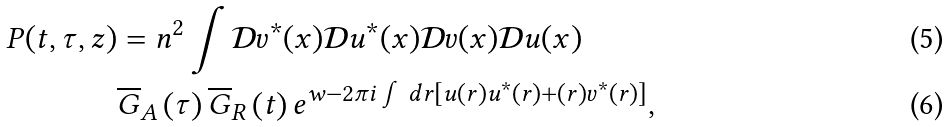Convert formula to latex. <formula><loc_0><loc_0><loc_500><loc_500>P ( t , \tau , z ) & = n ^ { 2 } \int \mathcal { D } v ^ { \ast } ( x ) \mathcal { D } u ^ { \ast } ( x ) \mathcal { D } v ( x ) \mathcal { D } u ( x ) \\ & \overline { G } _ { A } \left ( \tau \right ) \overline { G } _ { R } \left ( t \right ) e ^ { w - 2 \pi i \int d r \left [ u ( r ) u ^ { \ast } ( r ) + ( r ) v ^ { \ast } ( r ) \right ] } ,</formula> 